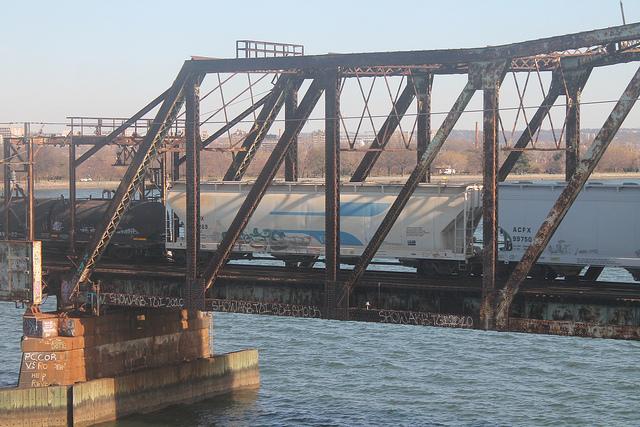Is the bridge made out of steel beams?
Keep it brief. Yes. Is there a train on the bridge?
Concise answer only. Yes. Is the bridge over water?
Give a very brief answer. Yes. 